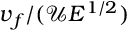<formula> <loc_0><loc_0><loc_500><loc_500>v _ { f } / ( \mathcal { U } E ^ { 1 / 2 } )</formula> 